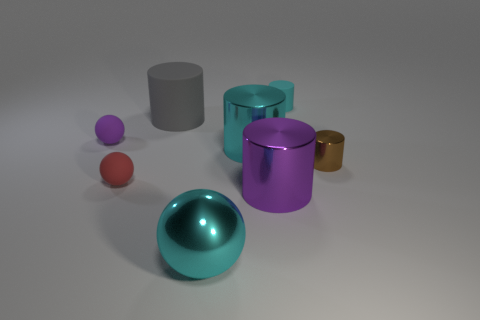Is there a gray rubber thing of the same shape as the large purple metallic object?
Your answer should be compact. Yes. What shape is the small red thing?
Make the answer very short. Sphere. What number of objects are gray objects or small cyan metal blocks?
Ensure brevity in your answer.  1. Do the cylinder to the right of the tiny matte cylinder and the matte cylinder on the right side of the large purple metal thing have the same size?
Offer a very short reply. Yes. What number of other objects are the same material as the big cyan ball?
Offer a terse response. 3. Are there more big cyan spheres that are in front of the tiny cyan rubber object than things to the right of the small purple matte object?
Give a very brief answer. No. There is a purple object right of the big matte object; what material is it?
Your response must be concise. Metal. Is the shape of the small purple rubber object the same as the large gray object?
Make the answer very short. No. Are there any other things of the same color as the metallic sphere?
Your response must be concise. Yes. The big thing that is the same shape as the tiny red thing is what color?
Keep it short and to the point. Cyan. 